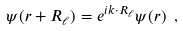<formula> <loc_0><loc_0><loc_500><loc_500>\psi ( { r + R _ { \ell } } ) = e ^ { i { k \cdot R _ { \ell } } } \psi ( { r } ) \ ,</formula> 